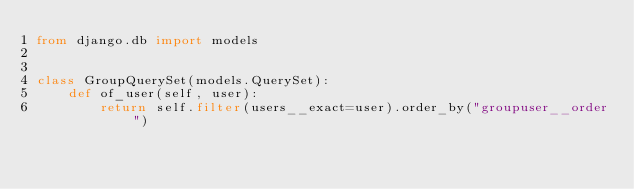Convert code to text. <code><loc_0><loc_0><loc_500><loc_500><_Python_>from django.db import models


class GroupQuerySet(models.QuerySet):
    def of_user(self, user):
        return self.filter(users__exact=user).order_by("groupuser__order")
</code> 